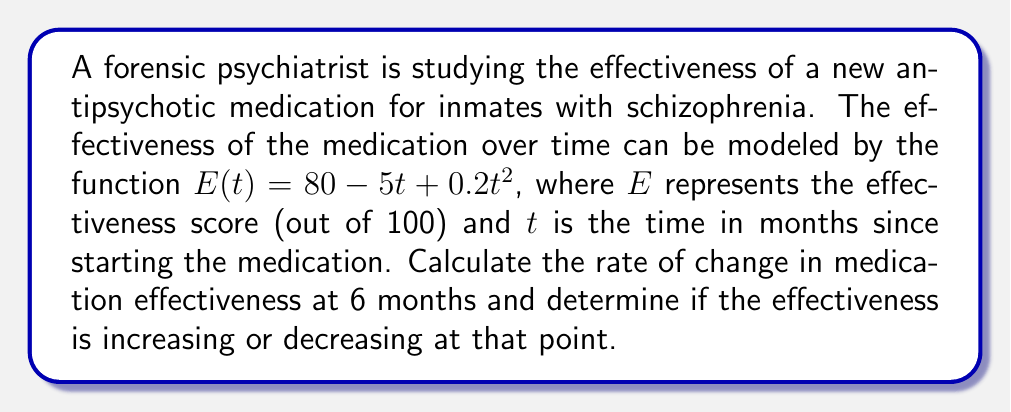Solve this math problem. To solve this problem, we need to use derivatives to find the rate of change in medication effectiveness.

1) First, let's find the derivative of the effectiveness function $E(t)$:
   
   $E(t) = 80 - 5t + 0.2t^2$
   
   $\frac{dE}{dt} = -5 + 0.4t$

2) This derivative represents the instantaneous rate of change of effectiveness with respect to time.

3) To find the rate of change at 6 months, we substitute $t = 6$ into the derivative:

   $\frac{dE}{dt}|_{t=6} = -5 + 0.4(6) = -5 + 2.4 = -2.6$

4) The negative value indicates that the effectiveness is decreasing at 6 months.

5) To interpret this result: At 6 months, the effectiveness of the medication is decreasing at a rate of 2.6 points per month.

6) To determine if the effectiveness is increasing or decreasing, we look at the sign of the derivative:
   - If positive, effectiveness is increasing
   - If negative, effectiveness is decreasing
   - If zero, effectiveness is neither increasing nor decreasing (at a stationary point)

   Since we found the derivative to be negative (-2.6), the effectiveness is decreasing at 6 months.
Answer: The rate of change in medication effectiveness at 6 months is -2.6 points per month, and the effectiveness is decreasing at that point. 